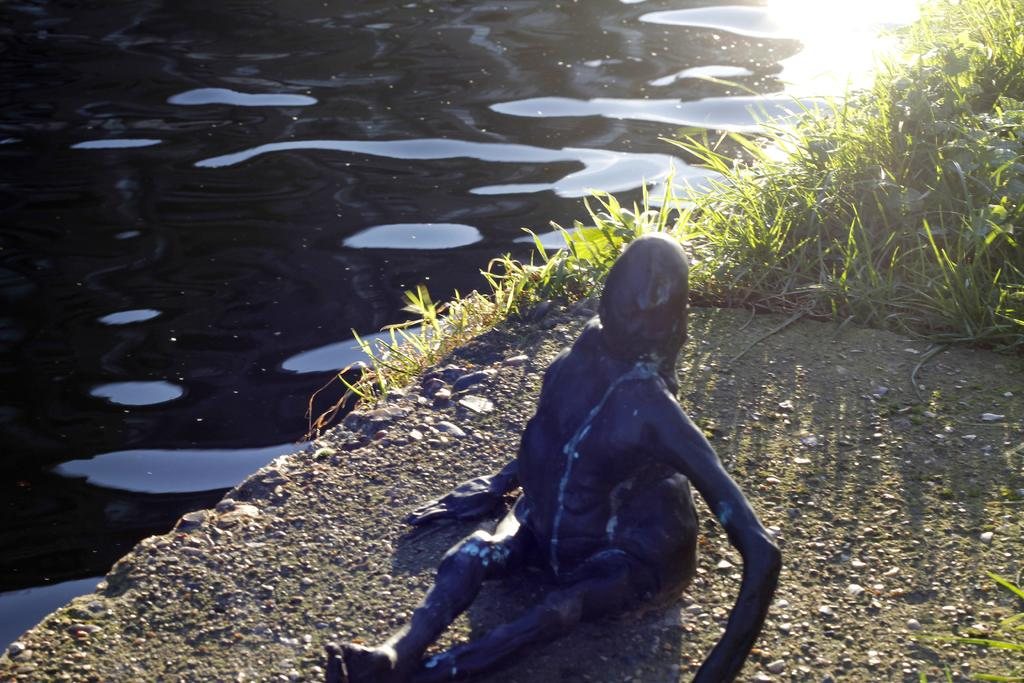What is the main subject in the middle of the image? There is a statue of a human in the middle of the image. What type of vegetation is on the right side of the image? There is grass on the right side of the image. What is on the left side of the image? There is water on the left side of the image. How many balls can be seen in the image? There are no balls present in the image. What color are the eyes of the statue in the image? The statue is not a living being and therefore does not have eyes. 